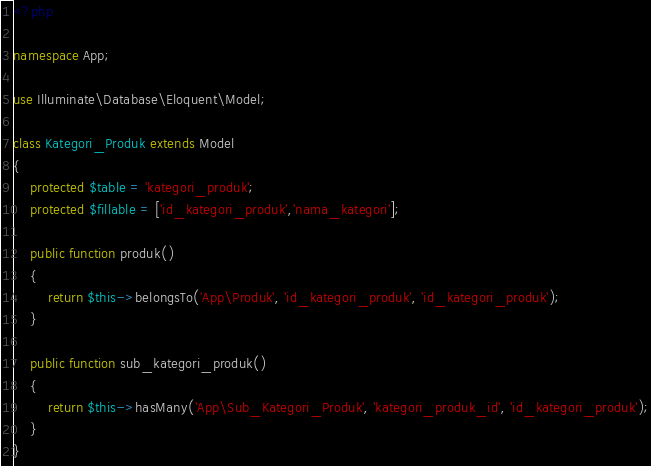<code> <loc_0><loc_0><loc_500><loc_500><_PHP_><?php

namespace App;

use Illuminate\Database\Eloquent\Model;

class Kategori_Produk extends Model
{
    protected $table = 'kategori_produk';
    protected $fillable = ['id_kategori_produk','nama_kategori'];

    public function produk()
    {
        return $this->belongsTo('App\Produk', 'id_kategori_produk', 'id_kategori_produk');
    }

    public function sub_kategori_produk()
    {
        return $this->hasMany('App\Sub_Kategori_Produk', 'kategori_produk_id', 'id_kategori_produk');
    }
}
</code> 